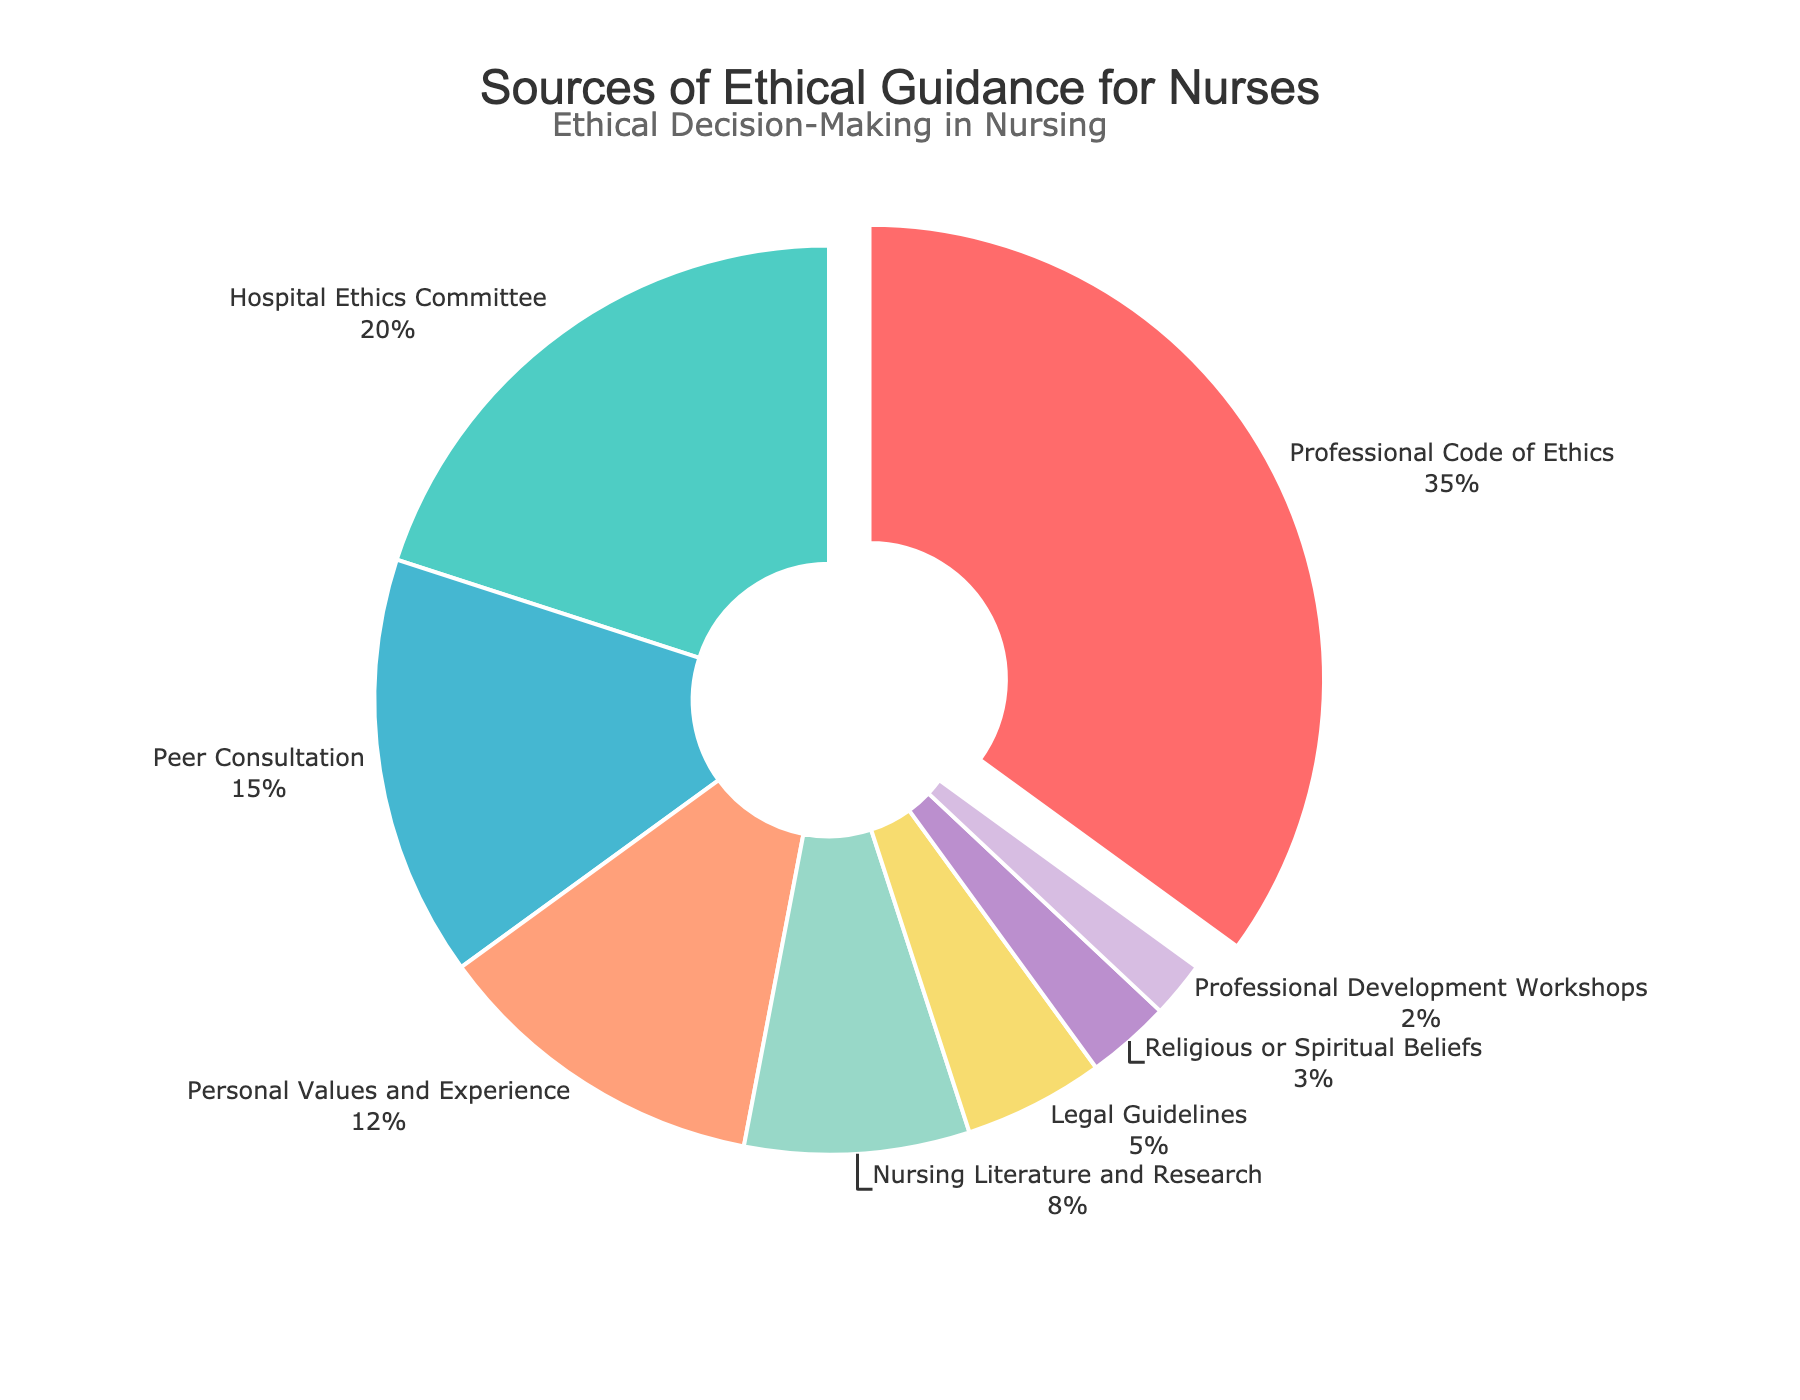What percentage of nurses consult the Hospital Ethics Committee for ethical guidance? The section labeled "Hospital Ethics Committee" represents a certain portion of the pie chart. That section's label shows it accounts for 20% of the total responses.
Answer: 20% Which source is most commonly consulted by nurses for ethical guidance and what is its percentage? The largest section of the pie chart, which is pulled out, is labeled "Professional Code of Ethics." This indicates that it is the most consulted source. The label indicates it accounts for 35% of the total responses.
Answer: Professional Code of Ethics, 35% What is the difference in percentage between nurses consulting their Personal Values and Experience and those consulting Legal Guidelines? From the pie chart, "Personal Values and Experience" accounts for 12% and "Legal Guidelines" accounts for 5%. The difference is calculated as 12% - 5%.
Answer: 7% What is the combined percentage of nurses consulting Peer Consultation and Nursing Literature and Research? Identify the sections "Peer Consultation" and "Nursing Literature and Research." Their percentages are 15% and 8%, respectively. Summing these gives 15% + 8%.
Answer: 23% How does the percentage of nurses consulting Professional Development Workshops compare to those consulting Religious or Spiritual Beliefs? The pie chart shows that "Professional Development Workshops" account for 2% and "Religious or Spiritual Beliefs" account for 3%. Comparatively, fewer nurses consult Professional Development Workshops than Religious or Spiritual Beliefs.
Answer: Fewer nurses consult Professional Development Workshops than Religious or Spiritual Beliefs What percentage of nurses consult sources other than the four most common ones? The four most common sources and their percentages are "Professional Code of Ethics" (35%), "Hospital Ethics Committee" (20%), "Peer Consultation" (15%), and "Personal Values and Experience" (12%). Summing these gives 35% + 20% + 15% + 12% = 82%. The remaining percentage is 100% - 82%.
Answer: 18% Arrange the sources in descending order of consultation percentages. Based on the chart, we list the sources from the highest to the lowest percentages: "Professional Code of Ethics" (35%), "Hospital Ethics Committee" (20%), "Peer Consultation" (15%), "Personal Values and Experience" (12%), "Nursing Literature and Research" (8%), "Legal Guidelines" (5%), "Religious or Spiritual Beliefs" (3%), "Professional Development Workshops" (2%).
Answer: Professional Code of Ethics, Hospital Ethics Committee, Peer Consultation, Personal Values and Experience, Nursing Literature and Research, Legal Guidelines, Religious or Spiritual Beliefs, Professional Development Workshops If the percentages for Peer Consultation and Personal Values and Experience are combined, will they exceed that of the Hospital Ethics Committee? The percentages are "Peer Consultation" (15%) and "Personal Values and Experience" (12%). Their sum is 15% + 12% = 27%. Compared to the "Hospital Ethics Committee" at 20%, the combined percentage of Peer Consultation and Personal Values and Experience is higher.
Answer: Yes What portion of the pie chart is used to represent Peer Consultation? The "Peer Consultation" section on the pie chart is indicated to be 15% of the total.
Answer: 15% 